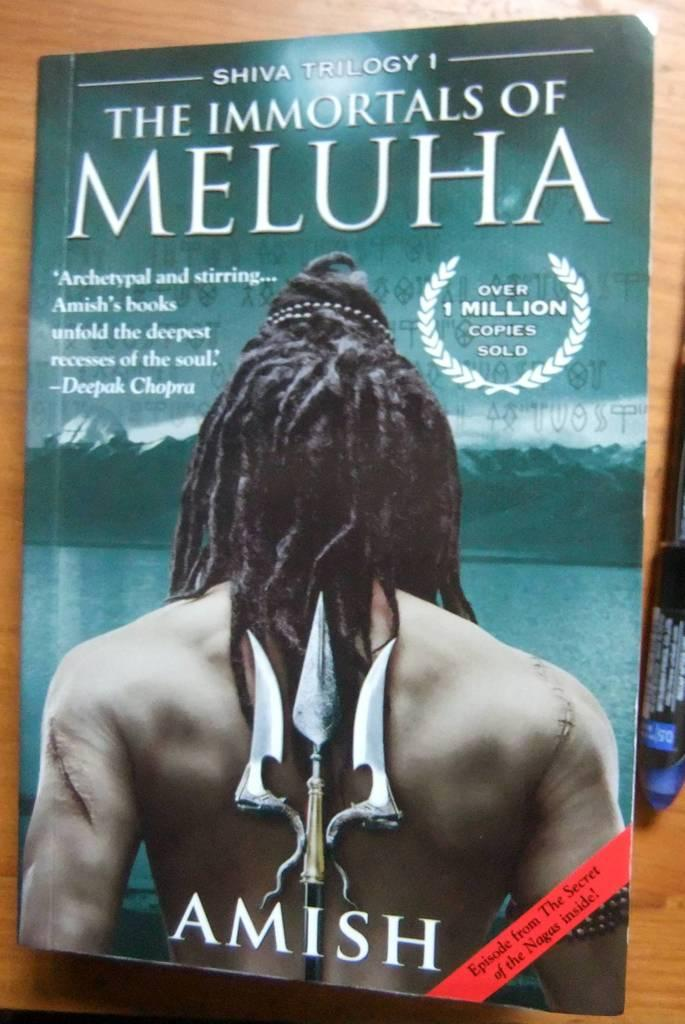<image>
Describe the image concisely. The book The Immortals of Meluha sits on a brown table. 